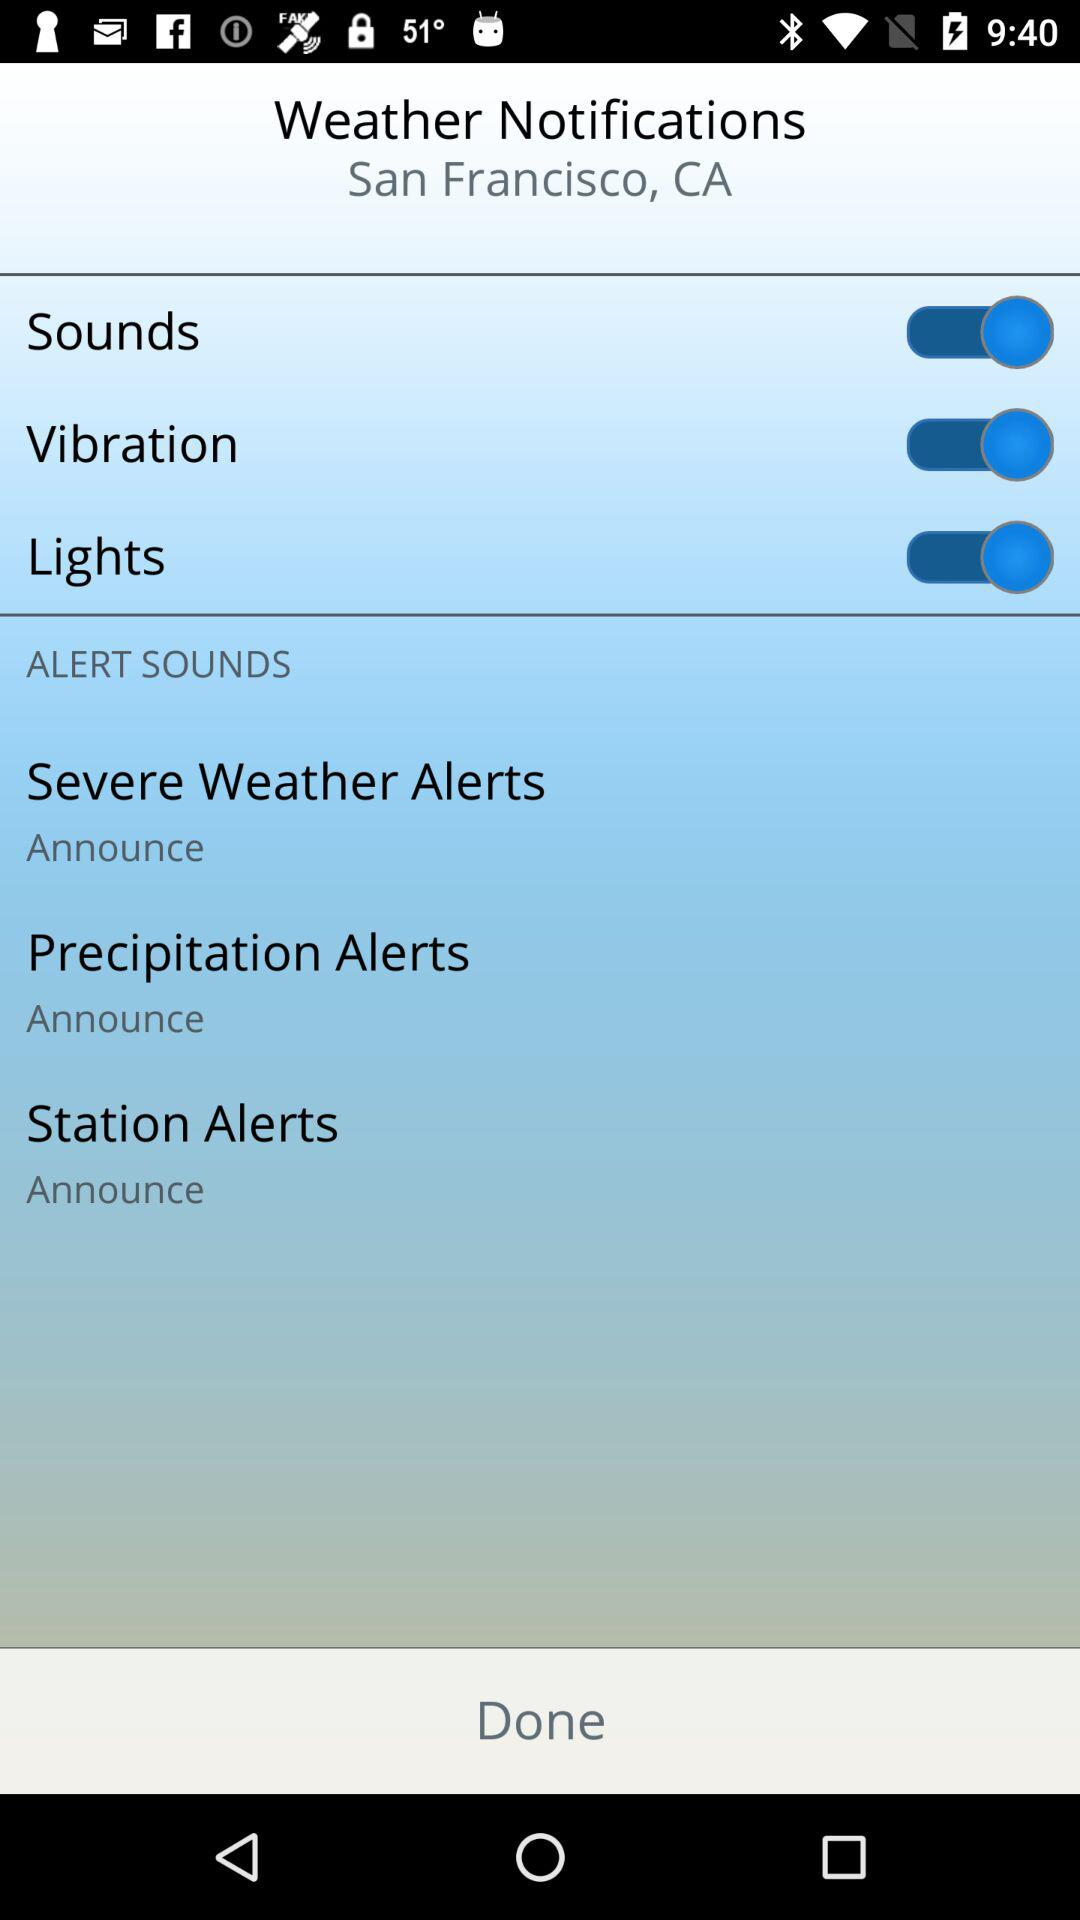How many alert sounds does the weather app have?
Answer the question using a single word or phrase. 3 